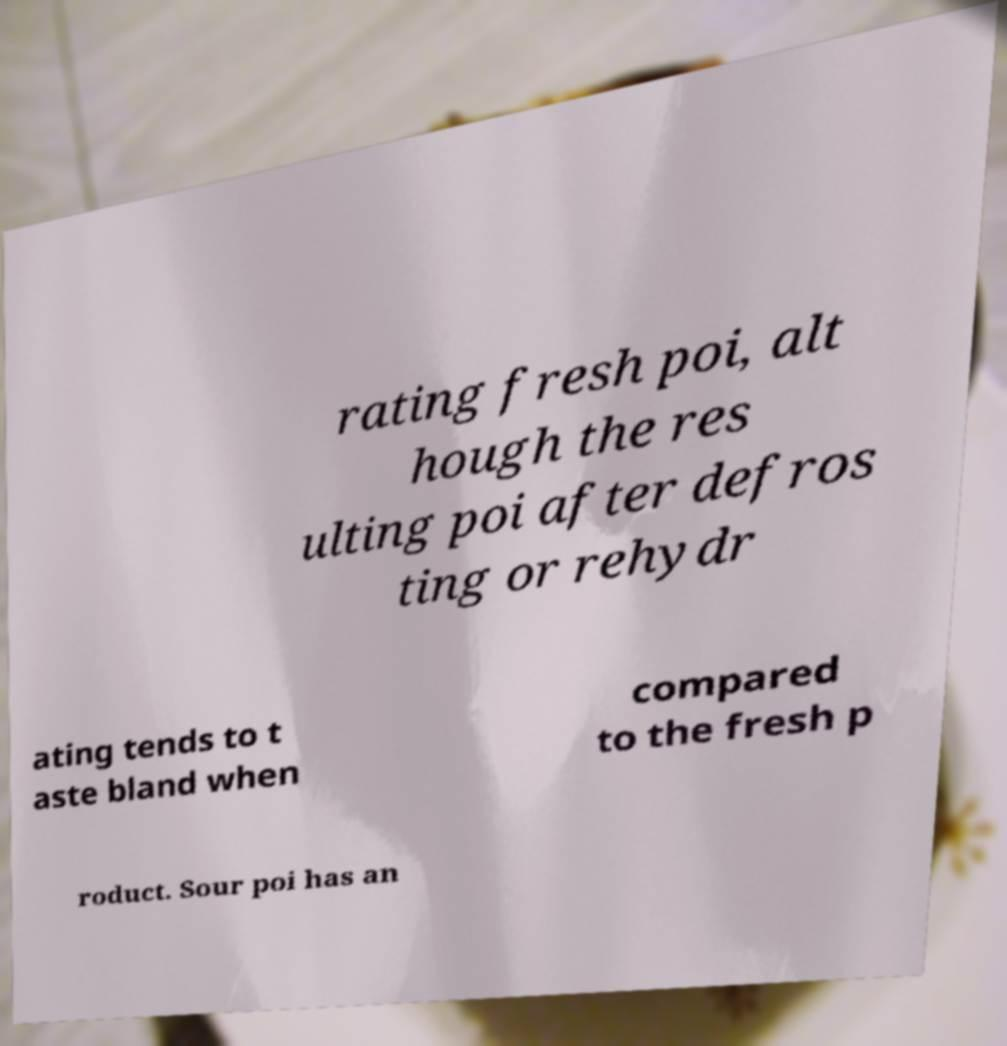Please read and relay the text visible in this image. What does it say? rating fresh poi, alt hough the res ulting poi after defros ting or rehydr ating tends to t aste bland when compared to the fresh p roduct. Sour poi has an 